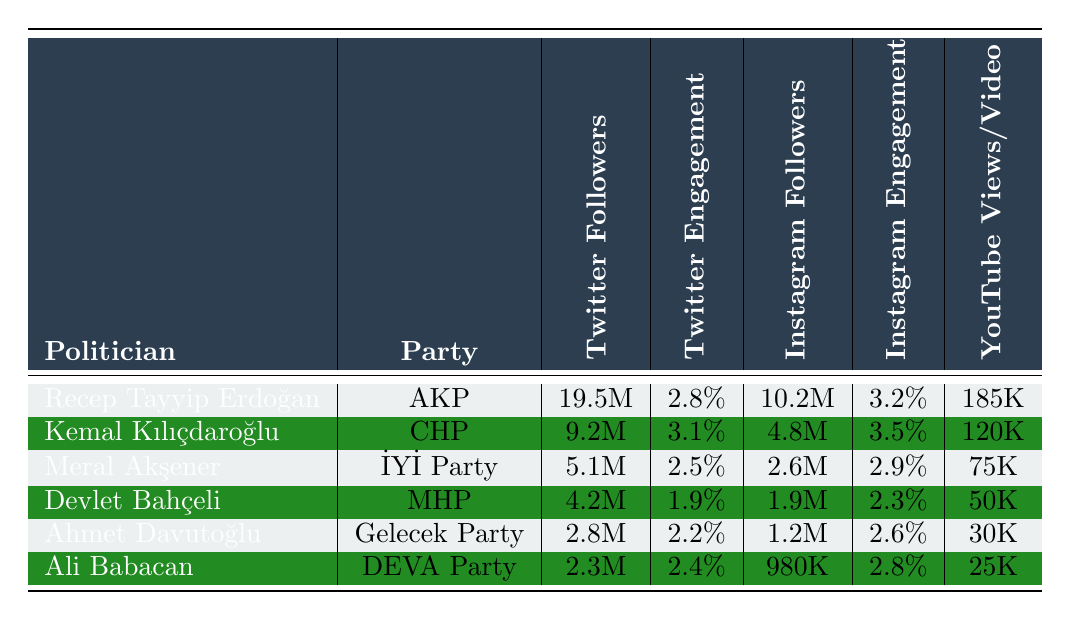What is the total number of Twitter followers for all the politicians listed? To find the total number of Twitter followers, we add the individual amounts: 19.5M + 9.2M + 5.1M + 4.2M + 2.8M + 2.3M = 43.1M.
Answer: 43.1M Which politician has the highest Instagram engagement rate? Looking at the Instagram engagement rates, Kemal Kılıçdaroğlu has the highest at 3.5%.
Answer: Kemal Kılıçdaroğlu What is the average Facebook engagement rate among the politicians? To find the average, sum the individual rates: 1.9% + 2.2% + 1.7% + 1.5% + 1.8% + 2.0% = 11.1%. Then divide by 6 (the number of politicians): 11.1% / 6 = 1.85%.
Answer: 1.85% Does Recep Tayyip Erdoğan have more Instagram followers than Meral Akşener? Recep Tayyip Erdoğan has 10.2M Instagram followers while Meral Akşener has 2.6M. Therefore, Erdoğan has more followers.
Answer: Yes Which party has the lowest average Twitter engagement rate? The engagement rates for each politician are: AKP 2.8%, CHP 3.1%, İYİ Party 2.5%, MHP 1.9%, Gelecek Party 2.2%, DEVA Party 2.4%. Adding them gives us 12.9%, and dividing by 6 results in an average of 2.15%. Hence, the MHP’s 1.9% is the lowest engagement rate.
Answer: MHP How many YouTube views does Meral Akşener receive per video compared to Ahmet Davutoğlu? Meral Akşener has 75K YouTube views per video, while Ahmet Davutoğlu has 30K. Subtracting the two gives us 75K - 30K = 45K, indicating she gets 45K more views per video.
Answer: 45K more Is the number of Facebook likes for Kemal Kılıçdaroğlu greater than that for Devlet Bahçeli? Kemal Kılıçdaroğlu has 3.5M Facebook likes, while Devlet Bahçeli has 1.5M. Since 3.5M is greater than 1.5M, the statement is true.
Answer: Yes Who has the least number of YouTube subscribers and what is that number? Reviewing the YouTube subscribers, Ali Babacan has the least at 70K subscribers.
Answer: 70K 